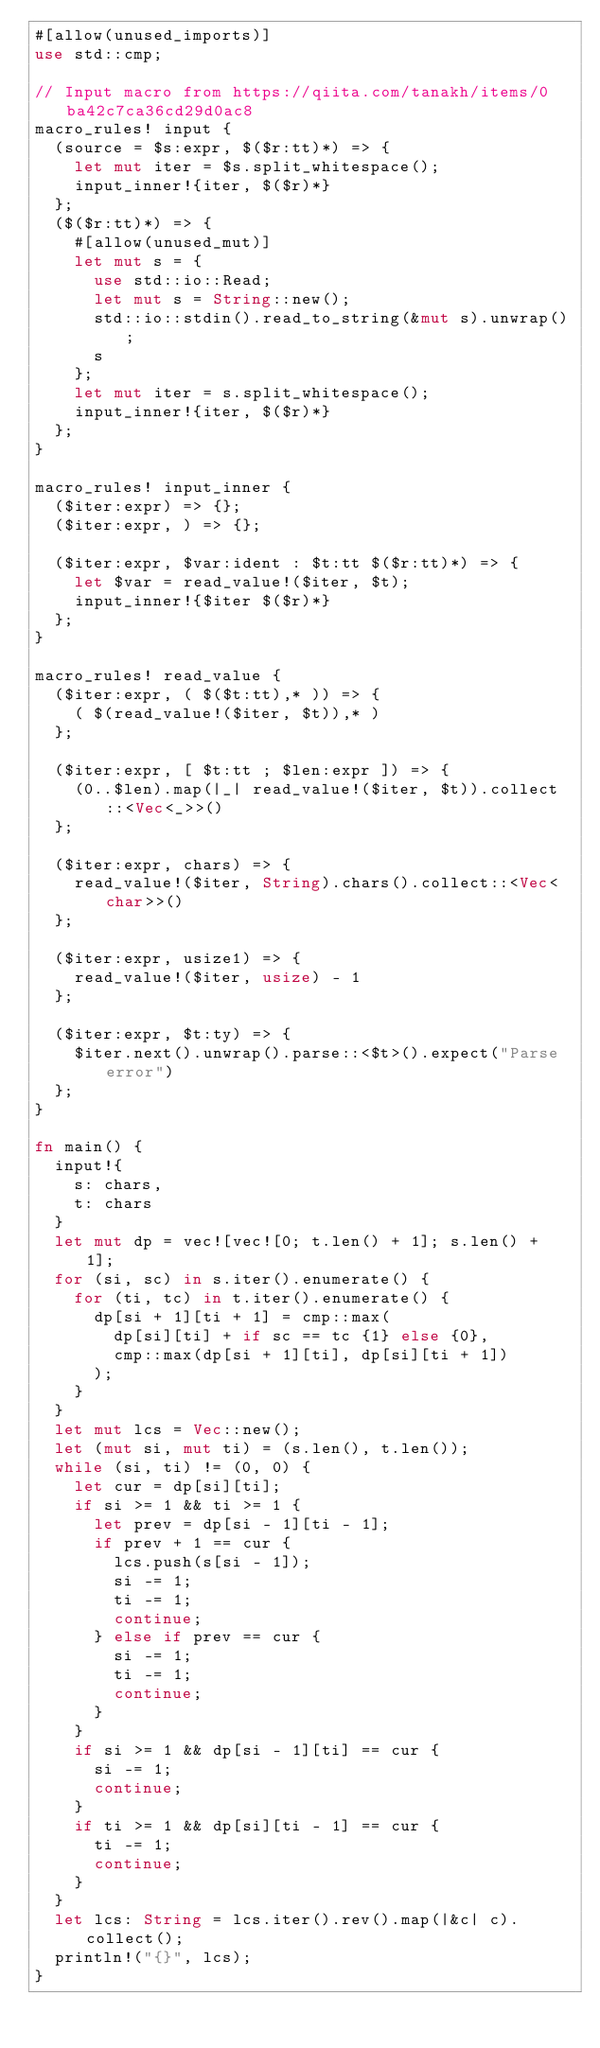Convert code to text. <code><loc_0><loc_0><loc_500><loc_500><_Rust_>#[allow(unused_imports)]
use std::cmp;

// Input macro from https://qiita.com/tanakh/items/0ba42c7ca36cd29d0ac8
macro_rules! input {
  (source = $s:expr, $($r:tt)*) => {
    let mut iter = $s.split_whitespace();
    input_inner!{iter, $($r)*}
  };
  ($($r:tt)*) => {
    #[allow(unused_mut)]
    let mut s = {
      use std::io::Read;
      let mut s = String::new();
      std::io::stdin().read_to_string(&mut s).unwrap();
      s
    };
    let mut iter = s.split_whitespace();
    input_inner!{iter, $($r)*}
  };
}

macro_rules! input_inner {
  ($iter:expr) => {};
  ($iter:expr, ) => {};

  ($iter:expr, $var:ident : $t:tt $($r:tt)*) => {
    let $var = read_value!($iter, $t);
    input_inner!{$iter $($r)*}
  };
}

macro_rules! read_value {
  ($iter:expr, ( $($t:tt),* )) => {
    ( $(read_value!($iter, $t)),* )
  };

  ($iter:expr, [ $t:tt ; $len:expr ]) => {
    (0..$len).map(|_| read_value!($iter, $t)).collect::<Vec<_>>()
  };

  ($iter:expr, chars) => {
    read_value!($iter, String).chars().collect::<Vec<char>>()
  };

  ($iter:expr, usize1) => {
    read_value!($iter, usize) - 1
  };

  ($iter:expr, $t:ty) => {
    $iter.next().unwrap().parse::<$t>().expect("Parse error")
  };
}

fn main() {
  input!{
    s: chars,
    t: chars
  }
  let mut dp = vec![vec![0; t.len() + 1]; s.len() + 1];
  for (si, sc) in s.iter().enumerate() {
    for (ti, tc) in t.iter().enumerate() {
      dp[si + 1][ti + 1] = cmp::max(
        dp[si][ti] + if sc == tc {1} else {0},
        cmp::max(dp[si + 1][ti], dp[si][ti + 1])
      );
    }
  }
  let mut lcs = Vec::new();
  let (mut si, mut ti) = (s.len(), t.len());
  while (si, ti) != (0, 0) {
    let cur = dp[si][ti];
    if si >= 1 && ti >= 1 {
      let prev = dp[si - 1][ti - 1];
      if prev + 1 == cur {
        lcs.push(s[si - 1]);
        si -= 1;
        ti -= 1;
        continue;
      } else if prev == cur {
        si -= 1;
        ti -= 1;
        continue;
      }
    }
    if si >= 1 && dp[si - 1][ti] == cur {
      si -= 1;
      continue;
    }
    if ti >= 1 && dp[si][ti - 1] == cur {
      ti -= 1;
      continue;
    }
  }
  let lcs: String = lcs.iter().rev().map(|&c| c).collect();
  println!("{}", lcs);
}
</code> 